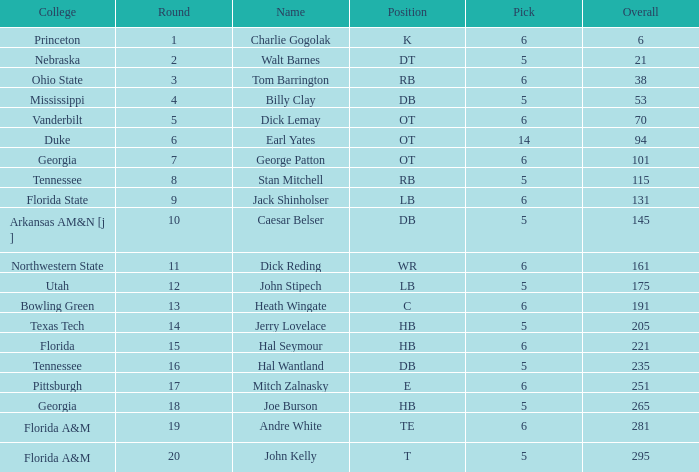What is the highest Pick, when Round is greater than 15, and when College is "Tennessee"? 5.0. 